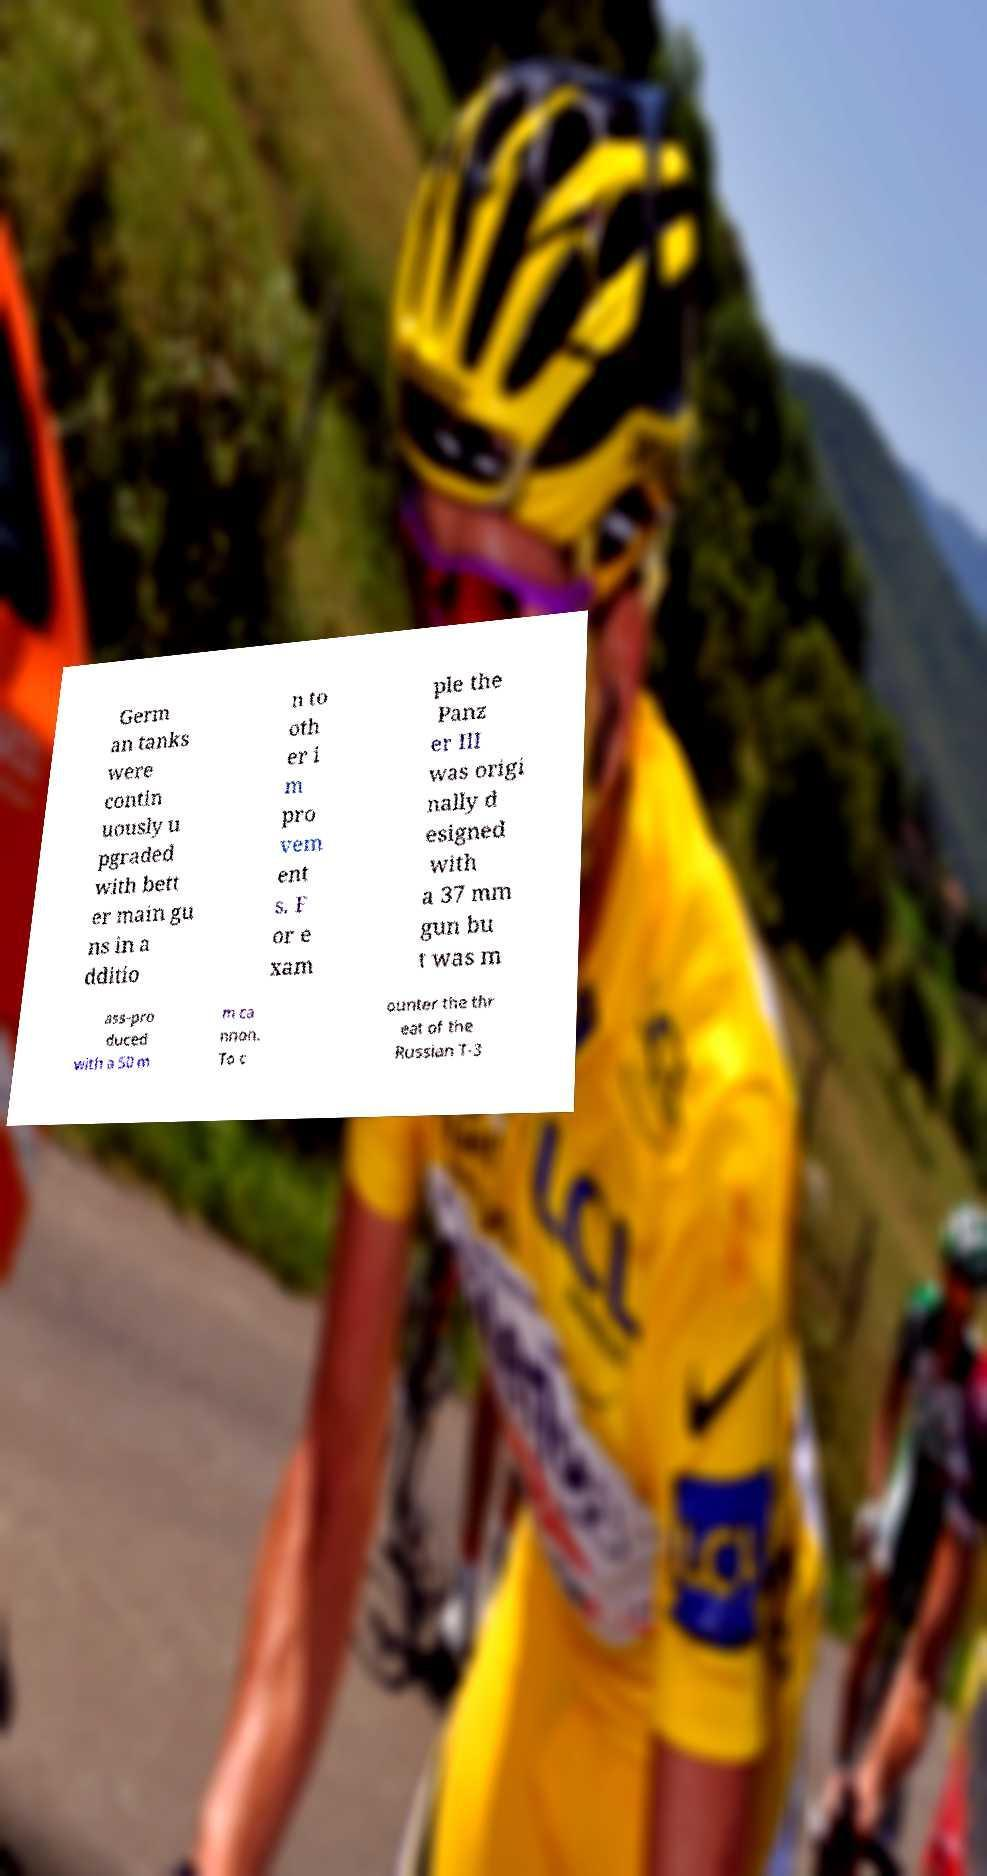I need the written content from this picture converted into text. Can you do that? Germ an tanks were contin uously u pgraded with bett er main gu ns in a dditio n to oth er i m pro vem ent s. F or e xam ple the Panz er III was origi nally d esigned with a 37 mm gun bu t was m ass-pro duced with a 50 m m ca nnon. To c ounter the thr eat of the Russian T-3 